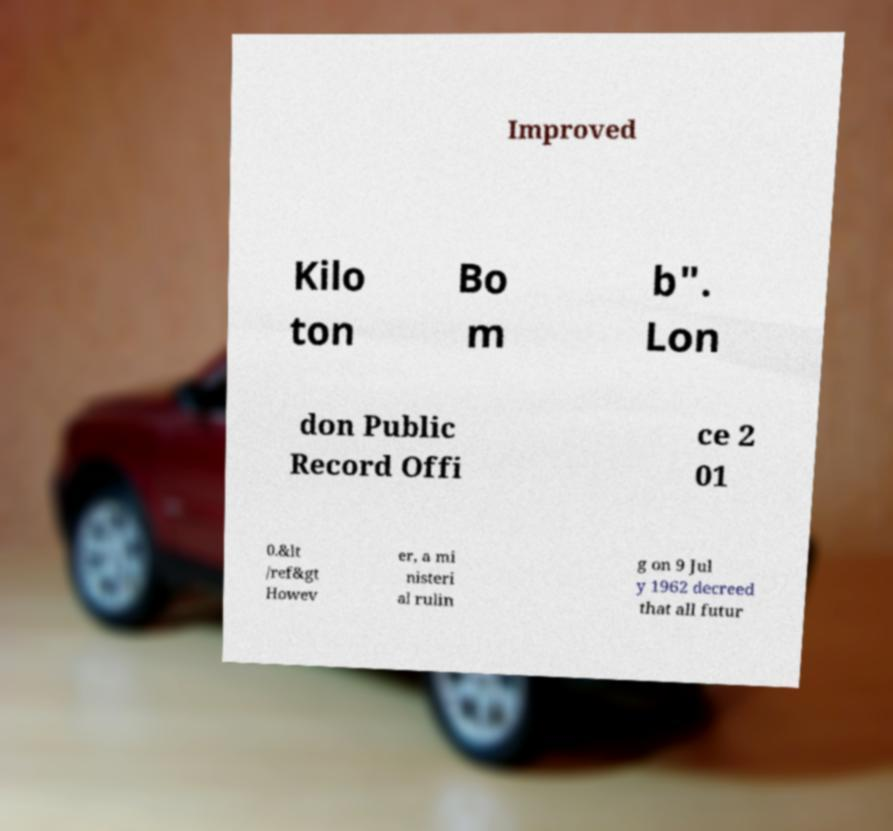Could you extract and type out the text from this image? Improved Kilo ton Bo m b". Lon don Public Record Offi ce 2 01 0.&lt /ref&gt Howev er, a mi nisteri al rulin g on 9 Jul y 1962 decreed that all futur 